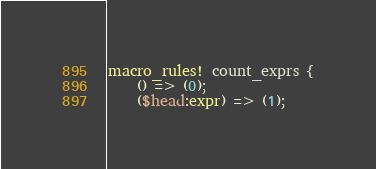Convert code to text. <code><loc_0><loc_0><loc_500><loc_500><_Rust_>macro_rules! count_exprs {
    () => (0);
    ($head:expr) => (1);</code> 